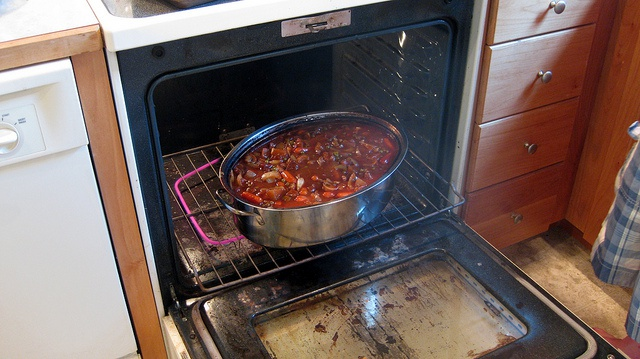Describe the objects in this image and their specific colors. I can see oven in lavender, black, navy, maroon, and gray tones and people in lavender, gray, darkgray, and darkblue tones in this image. 